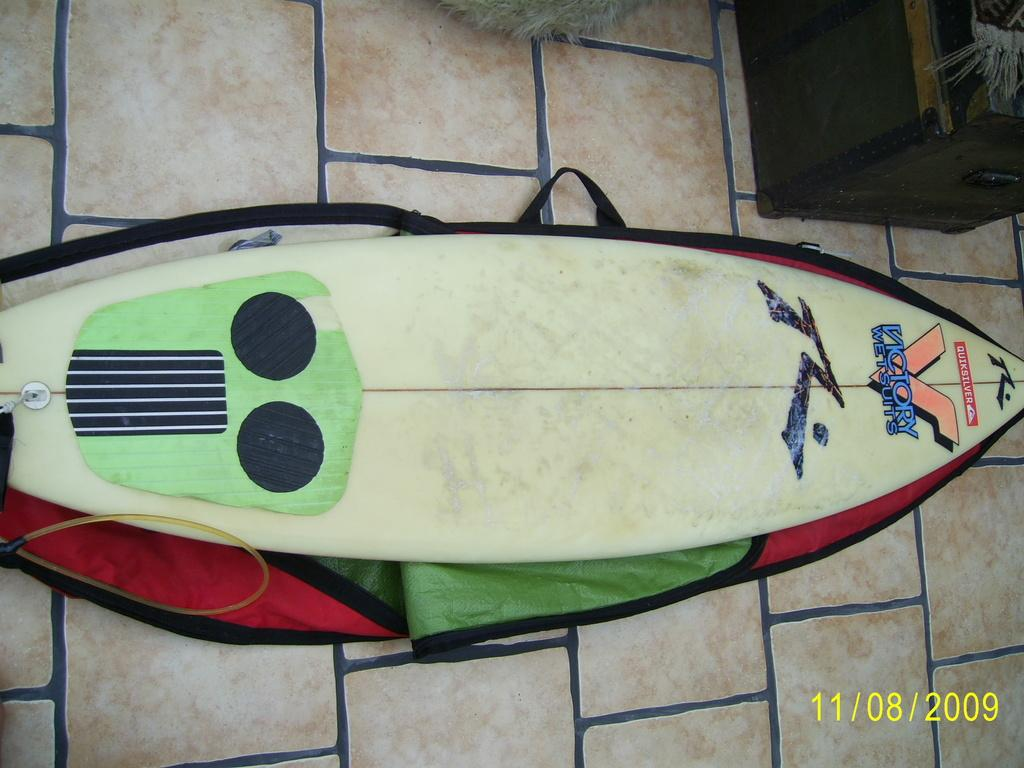What object is placed on the floor in the image? There is a surfboard on the floor in the image. What can be seen at the top of the image? There is a box at the top of the image. What information is provided at the bottom of the image? The date is mentioned at the bottom of the image. How many chairs are visible in the image? There are no chairs present in the image. What type of trick can be seen being performed with the surfboard in the image? There is no trick being performed with the surfboard in the image; it is simply placed on the floor. 